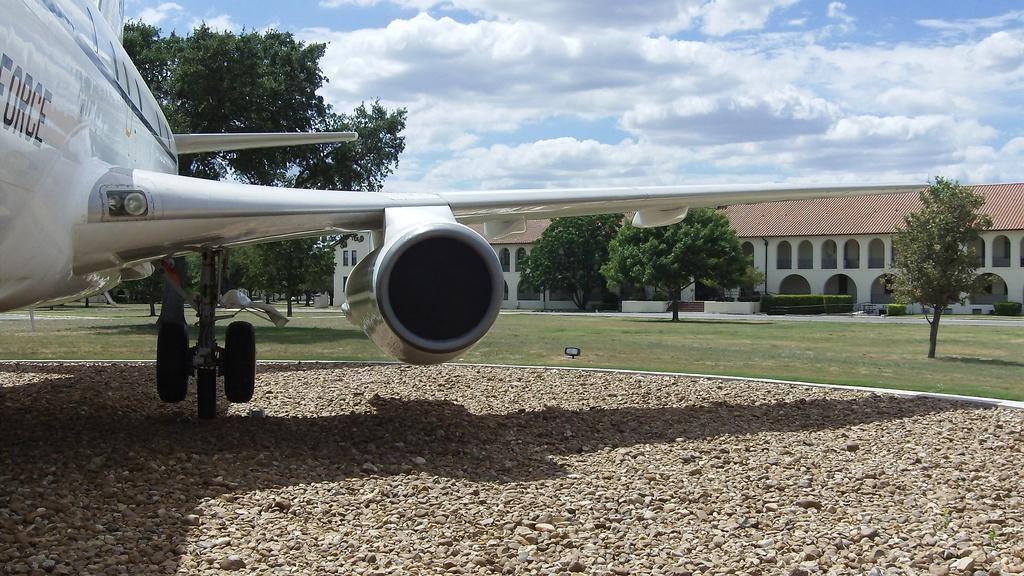<image>
Write a terse but informative summary of the picture. A white plane with Force written on it 